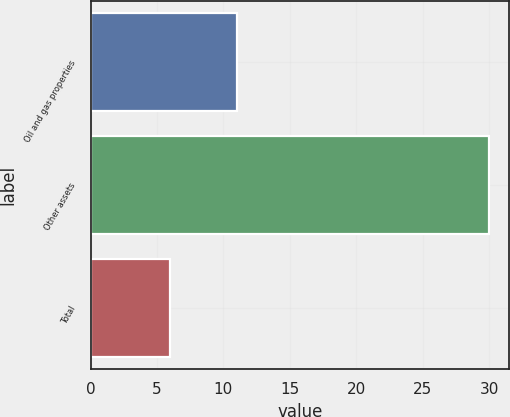<chart> <loc_0><loc_0><loc_500><loc_500><bar_chart><fcel>Oil and gas properties<fcel>Other assets<fcel>Total<nl><fcel>11<fcel>30<fcel>6<nl></chart> 